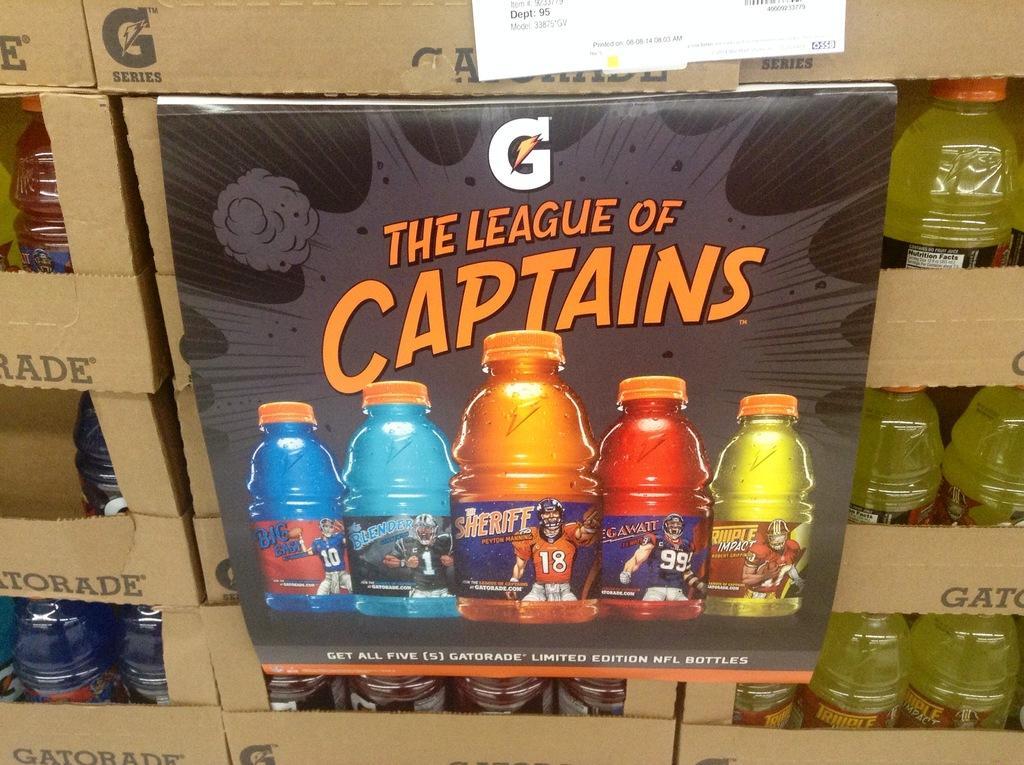Provide a one-sentence caption for the provided image. gatorade display with a sign in front showing the league of captains. 